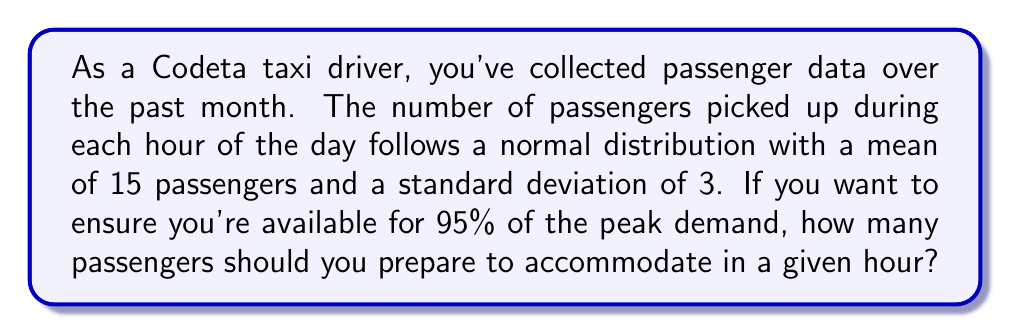Could you help me with this problem? To solve this problem, we need to use the properties of the normal distribution and the concept of z-scores. Let's break it down step-by-step:

1) We're given that the number of passengers per hour follows a normal distribution with:
   Mean (μ) = 15 passengers
   Standard deviation (σ) = 3 passengers

2) We want to find the number of passengers that corresponds to the 95th percentile, which means we need to find the z-score for the 95th percentile.

3) For a one-tailed test at 95%, the z-score is 1.645. We can use this because we're only interested in the upper tail (peak demand).

4) The formula to convert a z-score to a value in our distribution is:
   $$ X = μ + (z * σ) $$
   Where X is the value we're looking for, μ is the mean, z is the z-score, and σ is the standard deviation.

5) Plugging in our values:
   $$ X = 15 + (1.645 * 3) $$

6) Solving:
   $$ X = 15 + 4.935 = 19.935 $$

7) Since we're dealing with whole passengers, we round up to the nearest integer.

Therefore, to accommodate 95% of peak demand, you should prepare for 20 passengers in a given hour.
Answer: 20 passengers 